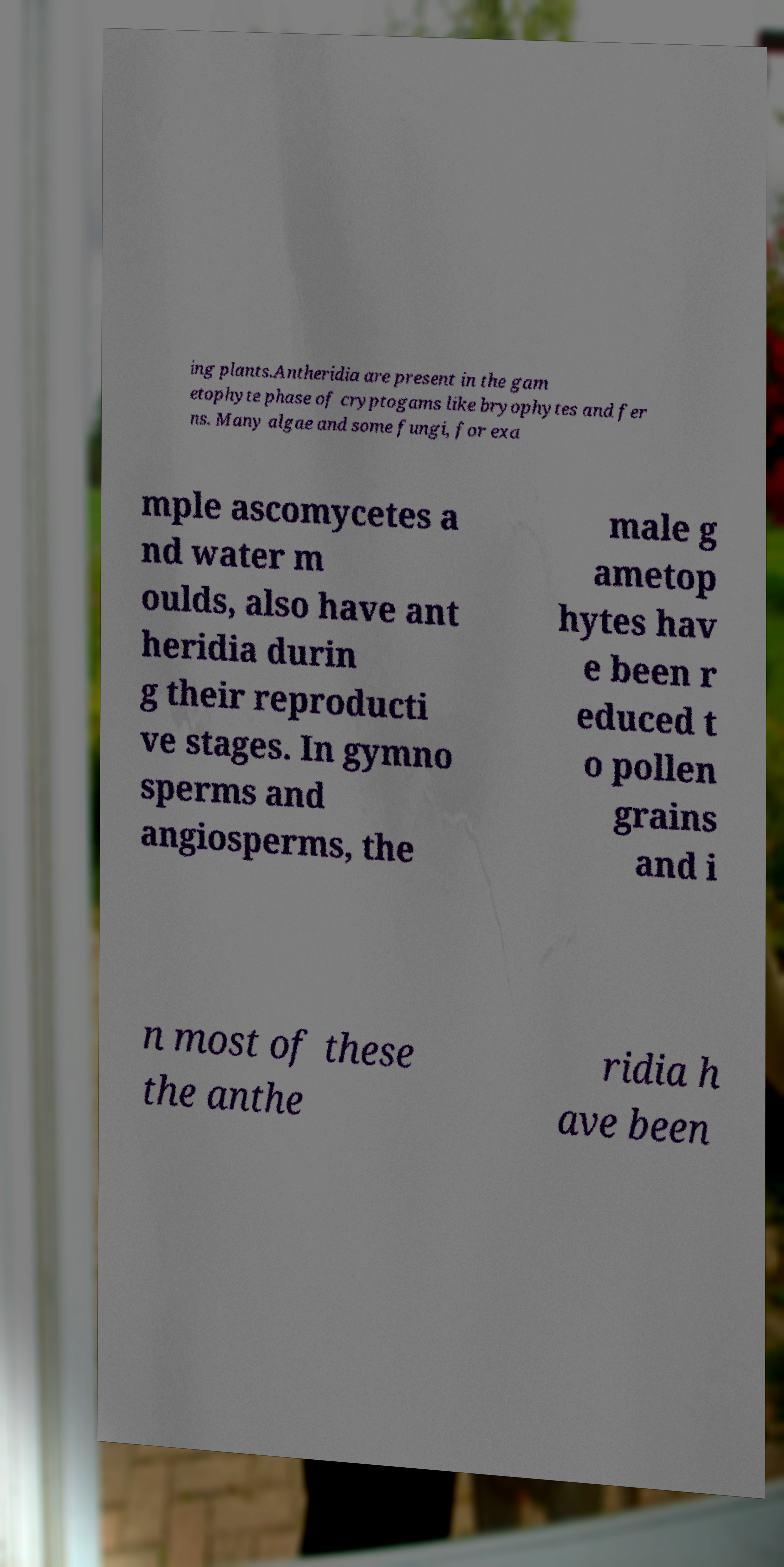For documentation purposes, I need the text within this image transcribed. Could you provide that? ing plants.Antheridia are present in the gam etophyte phase of cryptogams like bryophytes and fer ns. Many algae and some fungi, for exa mple ascomycetes a nd water m oulds, also have ant heridia durin g their reproducti ve stages. In gymno sperms and angiosperms, the male g ametop hytes hav e been r educed t o pollen grains and i n most of these the anthe ridia h ave been 